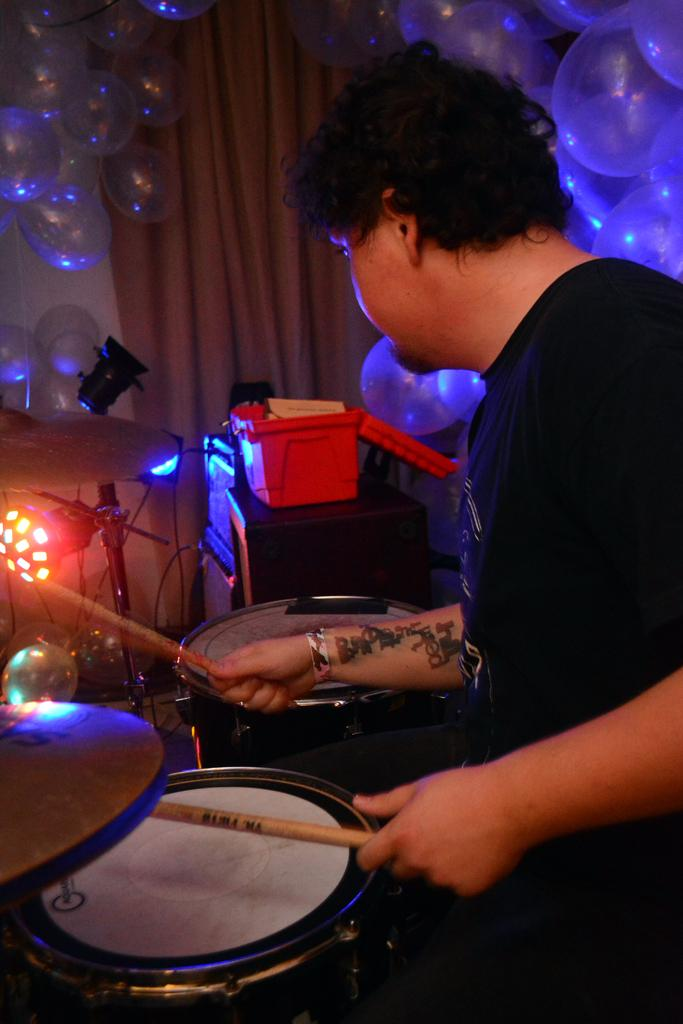What is the person in the image doing? The person is playing a musical instrument in the image. What additional items can be seen in the image? There are balloons and other objects in the image. What can be seen in the background of the image? There is a curtain in the background of the image. What type of apparel is the person wearing in the image? The provided facts do not mention any specific apparel worn by the person in the image. 